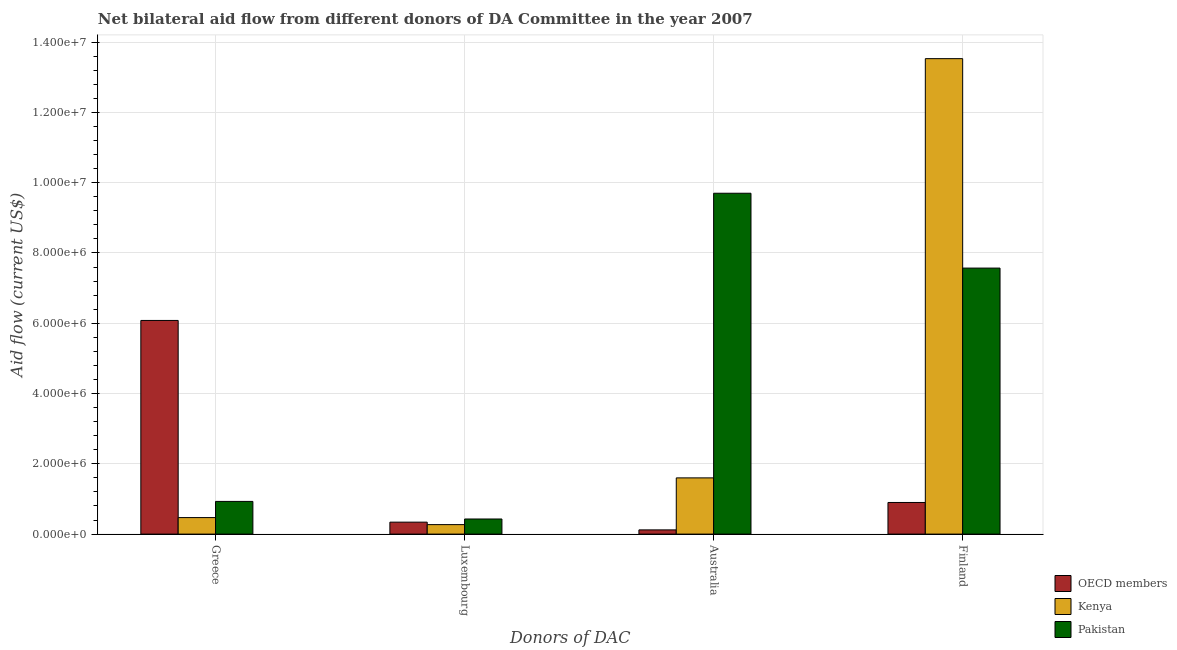How many different coloured bars are there?
Give a very brief answer. 3. How many groups of bars are there?
Offer a very short reply. 4. Are the number of bars on each tick of the X-axis equal?
Provide a short and direct response. Yes. How many bars are there on the 2nd tick from the left?
Provide a short and direct response. 3. What is the amount of aid given by finland in Kenya?
Your response must be concise. 1.35e+07. Across all countries, what is the maximum amount of aid given by australia?
Provide a short and direct response. 9.70e+06. Across all countries, what is the minimum amount of aid given by australia?
Provide a short and direct response. 1.20e+05. In which country was the amount of aid given by greece minimum?
Make the answer very short. Kenya. What is the total amount of aid given by finland in the graph?
Your answer should be compact. 2.20e+07. What is the difference between the amount of aid given by finland in Pakistan and that in Kenya?
Offer a terse response. -5.96e+06. What is the difference between the amount of aid given by finland in Kenya and the amount of aid given by australia in Pakistan?
Provide a short and direct response. 3.83e+06. What is the average amount of aid given by australia per country?
Provide a succinct answer. 3.81e+06. What is the difference between the amount of aid given by greece and amount of aid given by luxembourg in OECD members?
Provide a short and direct response. 5.74e+06. In how many countries, is the amount of aid given by finland greater than 1600000 US$?
Offer a very short reply. 2. What is the ratio of the amount of aid given by australia in Kenya to that in Pakistan?
Your answer should be compact. 0.16. What is the difference between the highest and the second highest amount of aid given by finland?
Your answer should be very brief. 5.96e+06. What is the difference between the highest and the lowest amount of aid given by australia?
Keep it short and to the point. 9.58e+06. What does the 2nd bar from the left in Greece represents?
Offer a very short reply. Kenya. Is it the case that in every country, the sum of the amount of aid given by greece and amount of aid given by luxembourg is greater than the amount of aid given by australia?
Offer a very short reply. No. How many bars are there?
Keep it short and to the point. 12. How many countries are there in the graph?
Provide a succinct answer. 3. Are the values on the major ticks of Y-axis written in scientific E-notation?
Provide a succinct answer. Yes. Does the graph contain grids?
Provide a short and direct response. Yes. What is the title of the graph?
Your answer should be compact. Net bilateral aid flow from different donors of DA Committee in the year 2007. What is the label or title of the X-axis?
Provide a short and direct response. Donors of DAC. What is the Aid flow (current US$) of OECD members in Greece?
Ensure brevity in your answer.  6.08e+06. What is the Aid flow (current US$) in Kenya in Greece?
Your answer should be compact. 4.70e+05. What is the Aid flow (current US$) in Pakistan in Greece?
Keep it short and to the point. 9.30e+05. What is the Aid flow (current US$) in OECD members in Luxembourg?
Your answer should be compact. 3.40e+05. What is the Aid flow (current US$) of Kenya in Luxembourg?
Give a very brief answer. 2.70e+05. What is the Aid flow (current US$) in Pakistan in Luxembourg?
Provide a short and direct response. 4.30e+05. What is the Aid flow (current US$) of Kenya in Australia?
Give a very brief answer. 1.60e+06. What is the Aid flow (current US$) in Pakistan in Australia?
Your response must be concise. 9.70e+06. What is the Aid flow (current US$) of OECD members in Finland?
Your answer should be very brief. 9.00e+05. What is the Aid flow (current US$) in Kenya in Finland?
Your answer should be very brief. 1.35e+07. What is the Aid flow (current US$) in Pakistan in Finland?
Ensure brevity in your answer.  7.57e+06. Across all Donors of DAC, what is the maximum Aid flow (current US$) of OECD members?
Offer a very short reply. 6.08e+06. Across all Donors of DAC, what is the maximum Aid flow (current US$) in Kenya?
Give a very brief answer. 1.35e+07. Across all Donors of DAC, what is the maximum Aid flow (current US$) of Pakistan?
Offer a terse response. 9.70e+06. What is the total Aid flow (current US$) in OECD members in the graph?
Your response must be concise. 7.44e+06. What is the total Aid flow (current US$) of Kenya in the graph?
Your response must be concise. 1.59e+07. What is the total Aid flow (current US$) of Pakistan in the graph?
Provide a short and direct response. 1.86e+07. What is the difference between the Aid flow (current US$) in OECD members in Greece and that in Luxembourg?
Your answer should be compact. 5.74e+06. What is the difference between the Aid flow (current US$) of OECD members in Greece and that in Australia?
Your answer should be very brief. 5.96e+06. What is the difference between the Aid flow (current US$) in Kenya in Greece and that in Australia?
Keep it short and to the point. -1.13e+06. What is the difference between the Aid flow (current US$) of Pakistan in Greece and that in Australia?
Make the answer very short. -8.77e+06. What is the difference between the Aid flow (current US$) in OECD members in Greece and that in Finland?
Provide a succinct answer. 5.18e+06. What is the difference between the Aid flow (current US$) in Kenya in Greece and that in Finland?
Provide a short and direct response. -1.31e+07. What is the difference between the Aid flow (current US$) of Pakistan in Greece and that in Finland?
Your answer should be very brief. -6.64e+06. What is the difference between the Aid flow (current US$) of Kenya in Luxembourg and that in Australia?
Ensure brevity in your answer.  -1.33e+06. What is the difference between the Aid flow (current US$) in Pakistan in Luxembourg and that in Australia?
Offer a terse response. -9.27e+06. What is the difference between the Aid flow (current US$) of OECD members in Luxembourg and that in Finland?
Make the answer very short. -5.60e+05. What is the difference between the Aid flow (current US$) in Kenya in Luxembourg and that in Finland?
Keep it short and to the point. -1.33e+07. What is the difference between the Aid flow (current US$) in Pakistan in Luxembourg and that in Finland?
Give a very brief answer. -7.14e+06. What is the difference between the Aid flow (current US$) in OECD members in Australia and that in Finland?
Your answer should be compact. -7.80e+05. What is the difference between the Aid flow (current US$) in Kenya in Australia and that in Finland?
Provide a short and direct response. -1.19e+07. What is the difference between the Aid flow (current US$) in Pakistan in Australia and that in Finland?
Offer a very short reply. 2.13e+06. What is the difference between the Aid flow (current US$) in OECD members in Greece and the Aid flow (current US$) in Kenya in Luxembourg?
Offer a very short reply. 5.81e+06. What is the difference between the Aid flow (current US$) in OECD members in Greece and the Aid flow (current US$) in Pakistan in Luxembourg?
Make the answer very short. 5.65e+06. What is the difference between the Aid flow (current US$) in Kenya in Greece and the Aid flow (current US$) in Pakistan in Luxembourg?
Make the answer very short. 4.00e+04. What is the difference between the Aid flow (current US$) in OECD members in Greece and the Aid flow (current US$) in Kenya in Australia?
Offer a very short reply. 4.48e+06. What is the difference between the Aid flow (current US$) of OECD members in Greece and the Aid flow (current US$) of Pakistan in Australia?
Give a very brief answer. -3.62e+06. What is the difference between the Aid flow (current US$) in Kenya in Greece and the Aid flow (current US$) in Pakistan in Australia?
Provide a short and direct response. -9.23e+06. What is the difference between the Aid flow (current US$) of OECD members in Greece and the Aid flow (current US$) of Kenya in Finland?
Your response must be concise. -7.45e+06. What is the difference between the Aid flow (current US$) in OECD members in Greece and the Aid flow (current US$) in Pakistan in Finland?
Keep it short and to the point. -1.49e+06. What is the difference between the Aid flow (current US$) of Kenya in Greece and the Aid flow (current US$) of Pakistan in Finland?
Provide a short and direct response. -7.10e+06. What is the difference between the Aid flow (current US$) in OECD members in Luxembourg and the Aid flow (current US$) in Kenya in Australia?
Give a very brief answer. -1.26e+06. What is the difference between the Aid flow (current US$) in OECD members in Luxembourg and the Aid flow (current US$) in Pakistan in Australia?
Offer a terse response. -9.36e+06. What is the difference between the Aid flow (current US$) of Kenya in Luxembourg and the Aid flow (current US$) of Pakistan in Australia?
Make the answer very short. -9.43e+06. What is the difference between the Aid flow (current US$) in OECD members in Luxembourg and the Aid flow (current US$) in Kenya in Finland?
Offer a very short reply. -1.32e+07. What is the difference between the Aid flow (current US$) of OECD members in Luxembourg and the Aid flow (current US$) of Pakistan in Finland?
Ensure brevity in your answer.  -7.23e+06. What is the difference between the Aid flow (current US$) of Kenya in Luxembourg and the Aid flow (current US$) of Pakistan in Finland?
Offer a terse response. -7.30e+06. What is the difference between the Aid flow (current US$) of OECD members in Australia and the Aid flow (current US$) of Kenya in Finland?
Your response must be concise. -1.34e+07. What is the difference between the Aid flow (current US$) of OECD members in Australia and the Aid flow (current US$) of Pakistan in Finland?
Make the answer very short. -7.45e+06. What is the difference between the Aid flow (current US$) of Kenya in Australia and the Aid flow (current US$) of Pakistan in Finland?
Offer a terse response. -5.97e+06. What is the average Aid flow (current US$) in OECD members per Donors of DAC?
Offer a terse response. 1.86e+06. What is the average Aid flow (current US$) in Kenya per Donors of DAC?
Ensure brevity in your answer.  3.97e+06. What is the average Aid flow (current US$) in Pakistan per Donors of DAC?
Offer a very short reply. 4.66e+06. What is the difference between the Aid flow (current US$) of OECD members and Aid flow (current US$) of Kenya in Greece?
Give a very brief answer. 5.61e+06. What is the difference between the Aid flow (current US$) in OECD members and Aid flow (current US$) in Pakistan in Greece?
Provide a short and direct response. 5.15e+06. What is the difference between the Aid flow (current US$) in Kenya and Aid flow (current US$) in Pakistan in Greece?
Provide a short and direct response. -4.60e+05. What is the difference between the Aid flow (current US$) in OECD members and Aid flow (current US$) in Kenya in Luxembourg?
Offer a terse response. 7.00e+04. What is the difference between the Aid flow (current US$) of OECD members and Aid flow (current US$) of Pakistan in Luxembourg?
Keep it short and to the point. -9.00e+04. What is the difference between the Aid flow (current US$) of Kenya and Aid flow (current US$) of Pakistan in Luxembourg?
Make the answer very short. -1.60e+05. What is the difference between the Aid flow (current US$) in OECD members and Aid flow (current US$) in Kenya in Australia?
Provide a succinct answer. -1.48e+06. What is the difference between the Aid flow (current US$) in OECD members and Aid flow (current US$) in Pakistan in Australia?
Ensure brevity in your answer.  -9.58e+06. What is the difference between the Aid flow (current US$) in Kenya and Aid flow (current US$) in Pakistan in Australia?
Make the answer very short. -8.10e+06. What is the difference between the Aid flow (current US$) in OECD members and Aid flow (current US$) in Kenya in Finland?
Your answer should be compact. -1.26e+07. What is the difference between the Aid flow (current US$) in OECD members and Aid flow (current US$) in Pakistan in Finland?
Provide a short and direct response. -6.67e+06. What is the difference between the Aid flow (current US$) in Kenya and Aid flow (current US$) in Pakistan in Finland?
Ensure brevity in your answer.  5.96e+06. What is the ratio of the Aid flow (current US$) in OECD members in Greece to that in Luxembourg?
Ensure brevity in your answer.  17.88. What is the ratio of the Aid flow (current US$) in Kenya in Greece to that in Luxembourg?
Make the answer very short. 1.74. What is the ratio of the Aid flow (current US$) in Pakistan in Greece to that in Luxembourg?
Ensure brevity in your answer.  2.16. What is the ratio of the Aid flow (current US$) in OECD members in Greece to that in Australia?
Offer a terse response. 50.67. What is the ratio of the Aid flow (current US$) of Kenya in Greece to that in Australia?
Your answer should be compact. 0.29. What is the ratio of the Aid flow (current US$) of Pakistan in Greece to that in Australia?
Your response must be concise. 0.1. What is the ratio of the Aid flow (current US$) of OECD members in Greece to that in Finland?
Make the answer very short. 6.76. What is the ratio of the Aid flow (current US$) in Kenya in Greece to that in Finland?
Provide a short and direct response. 0.03. What is the ratio of the Aid flow (current US$) of Pakistan in Greece to that in Finland?
Keep it short and to the point. 0.12. What is the ratio of the Aid flow (current US$) of OECD members in Luxembourg to that in Australia?
Give a very brief answer. 2.83. What is the ratio of the Aid flow (current US$) of Kenya in Luxembourg to that in Australia?
Give a very brief answer. 0.17. What is the ratio of the Aid flow (current US$) of Pakistan in Luxembourg to that in Australia?
Offer a very short reply. 0.04. What is the ratio of the Aid flow (current US$) in OECD members in Luxembourg to that in Finland?
Your answer should be very brief. 0.38. What is the ratio of the Aid flow (current US$) in Kenya in Luxembourg to that in Finland?
Give a very brief answer. 0.02. What is the ratio of the Aid flow (current US$) in Pakistan in Luxembourg to that in Finland?
Provide a short and direct response. 0.06. What is the ratio of the Aid flow (current US$) of OECD members in Australia to that in Finland?
Keep it short and to the point. 0.13. What is the ratio of the Aid flow (current US$) of Kenya in Australia to that in Finland?
Offer a terse response. 0.12. What is the ratio of the Aid flow (current US$) of Pakistan in Australia to that in Finland?
Ensure brevity in your answer.  1.28. What is the difference between the highest and the second highest Aid flow (current US$) of OECD members?
Provide a succinct answer. 5.18e+06. What is the difference between the highest and the second highest Aid flow (current US$) in Kenya?
Make the answer very short. 1.19e+07. What is the difference between the highest and the second highest Aid flow (current US$) of Pakistan?
Keep it short and to the point. 2.13e+06. What is the difference between the highest and the lowest Aid flow (current US$) in OECD members?
Your response must be concise. 5.96e+06. What is the difference between the highest and the lowest Aid flow (current US$) in Kenya?
Give a very brief answer. 1.33e+07. What is the difference between the highest and the lowest Aid flow (current US$) of Pakistan?
Give a very brief answer. 9.27e+06. 